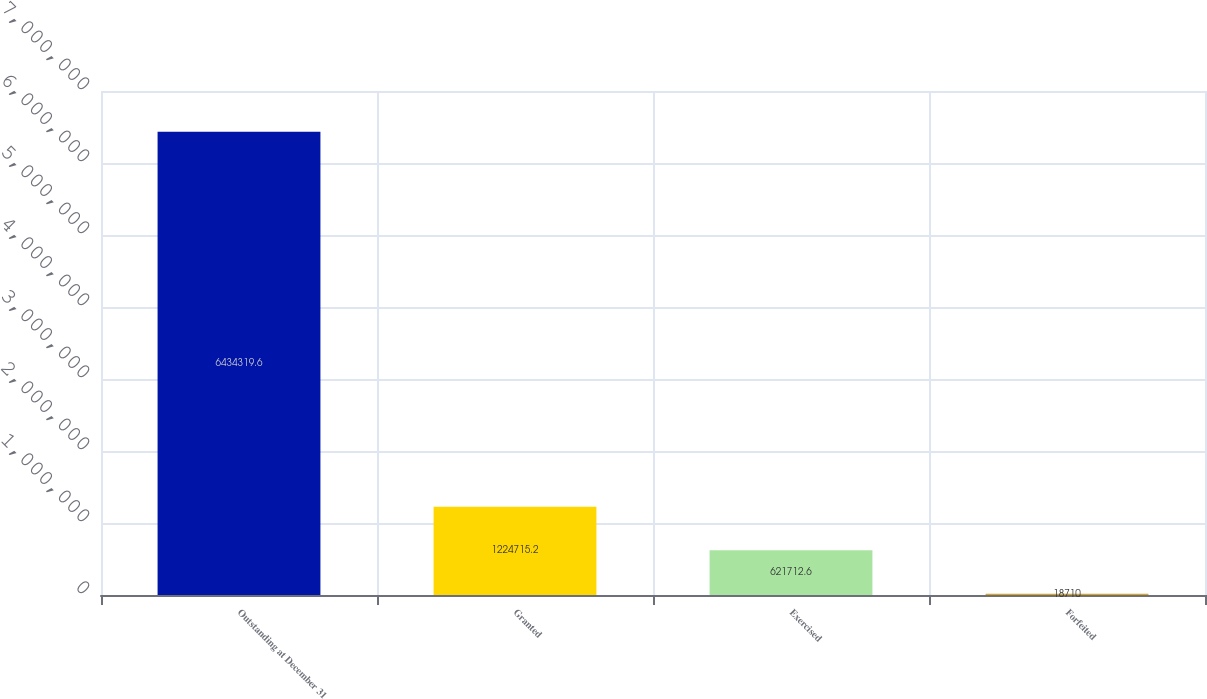Convert chart. <chart><loc_0><loc_0><loc_500><loc_500><bar_chart><fcel>Outstanding at December 31<fcel>Granted<fcel>Exercised<fcel>Forfeited<nl><fcel>6.43432e+06<fcel>1.22472e+06<fcel>621713<fcel>18710<nl></chart> 